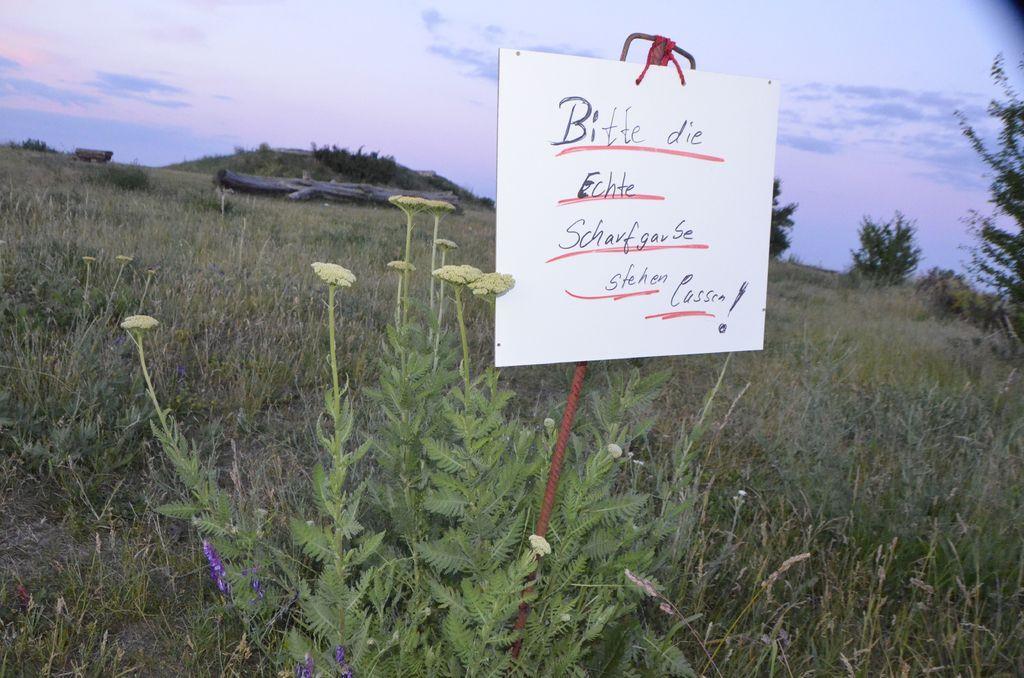Describe this image in one or two sentences. In this image we can see a board with text. In the background of the image there is sky, mountain, grass and plants. 